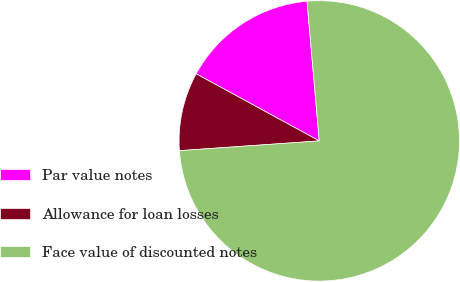Convert chart to OTSL. <chart><loc_0><loc_0><loc_500><loc_500><pie_chart><fcel>Par value notes<fcel>Allowance for loan losses<fcel>Face value of discounted notes<nl><fcel>15.67%<fcel>9.05%<fcel>75.28%<nl></chart> 